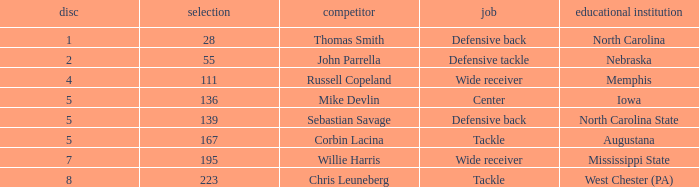What is the sum of Round with a Pick that is 55? 2.0. 